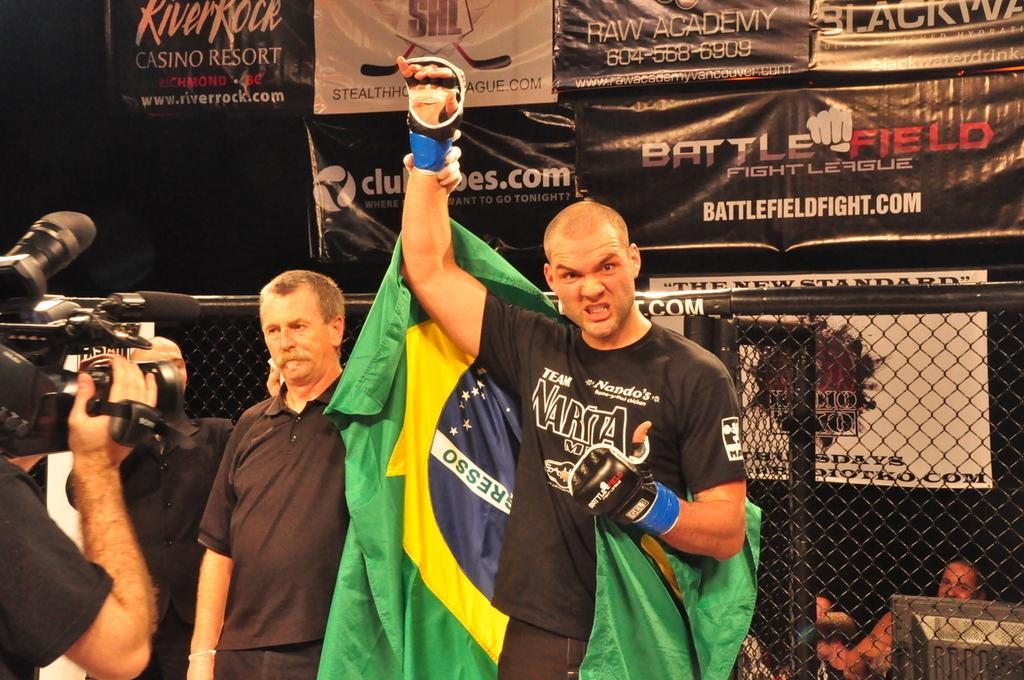<image>
Create a compact narrative representing the image presented. Narita reads the logo on this fighter's t shirt. 